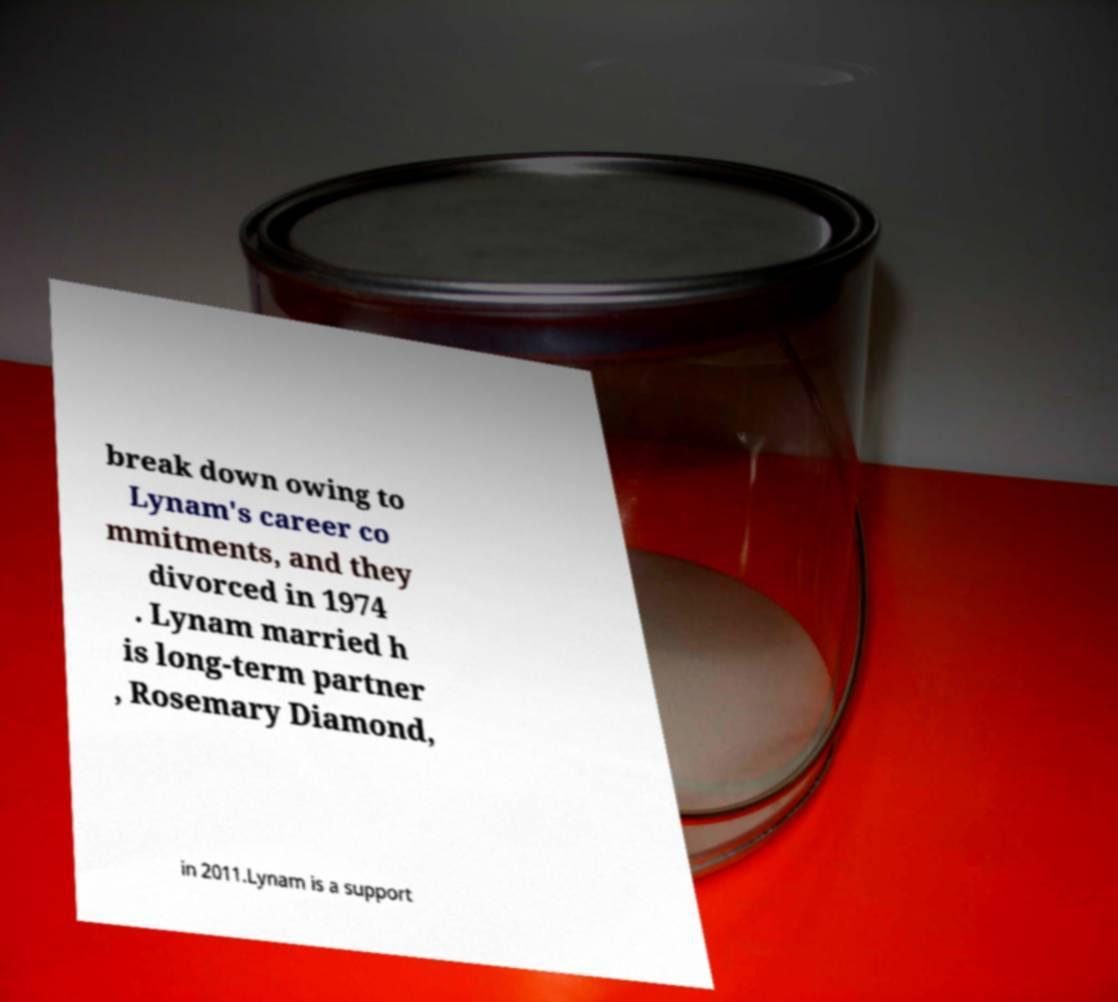I need the written content from this picture converted into text. Can you do that? break down owing to Lynam's career co mmitments, and they divorced in 1974 . Lynam married h is long-term partner , Rosemary Diamond, in 2011.Lynam is a support 